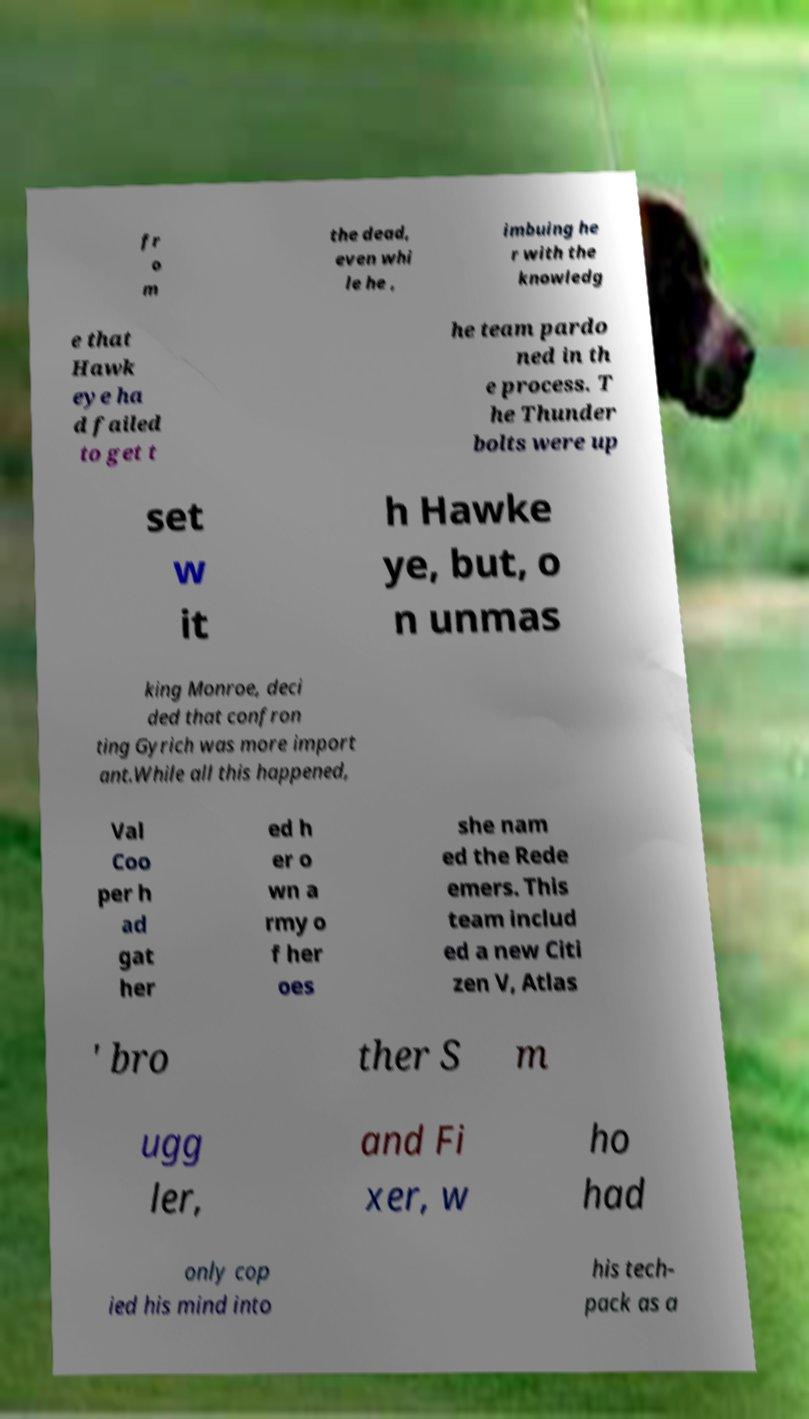I need the written content from this picture converted into text. Can you do that? fr o m the dead, even whi le he , imbuing he r with the knowledg e that Hawk eye ha d failed to get t he team pardo ned in th e process. T he Thunder bolts were up set w it h Hawke ye, but, o n unmas king Monroe, deci ded that confron ting Gyrich was more import ant.While all this happened, Val Coo per h ad gat her ed h er o wn a rmy o f her oes she nam ed the Rede emers. This team includ ed a new Citi zen V, Atlas ' bro ther S m ugg ler, and Fi xer, w ho had only cop ied his mind into his tech- pack as a 